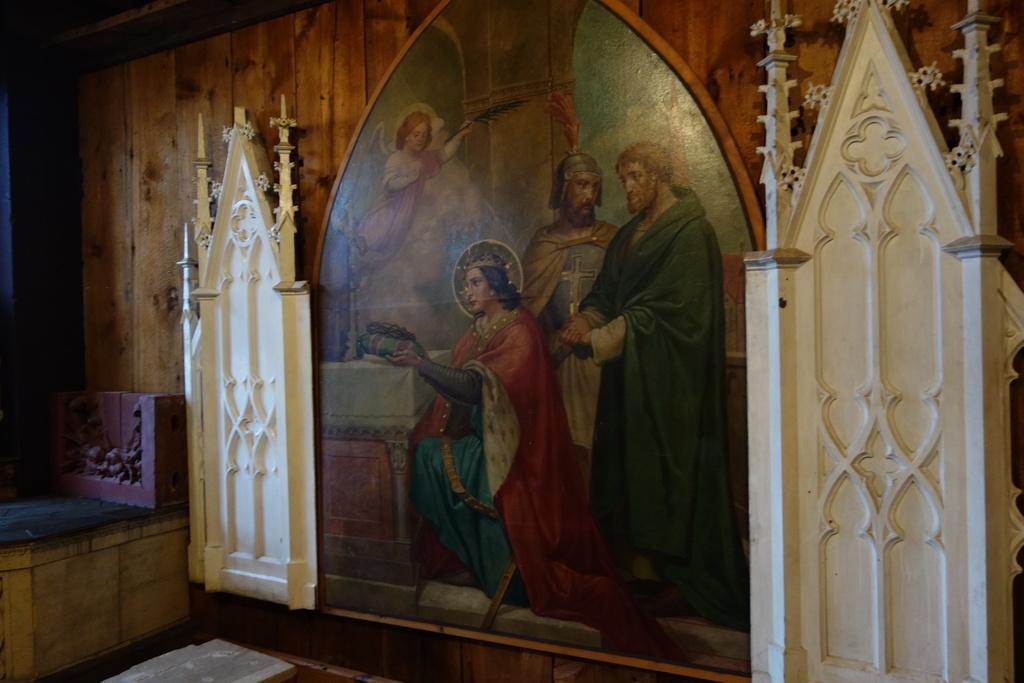How would you summarize this image in a sentence or two? There is a wooden wall. On that there is a painting and some decorations. On that painting there are persons. 